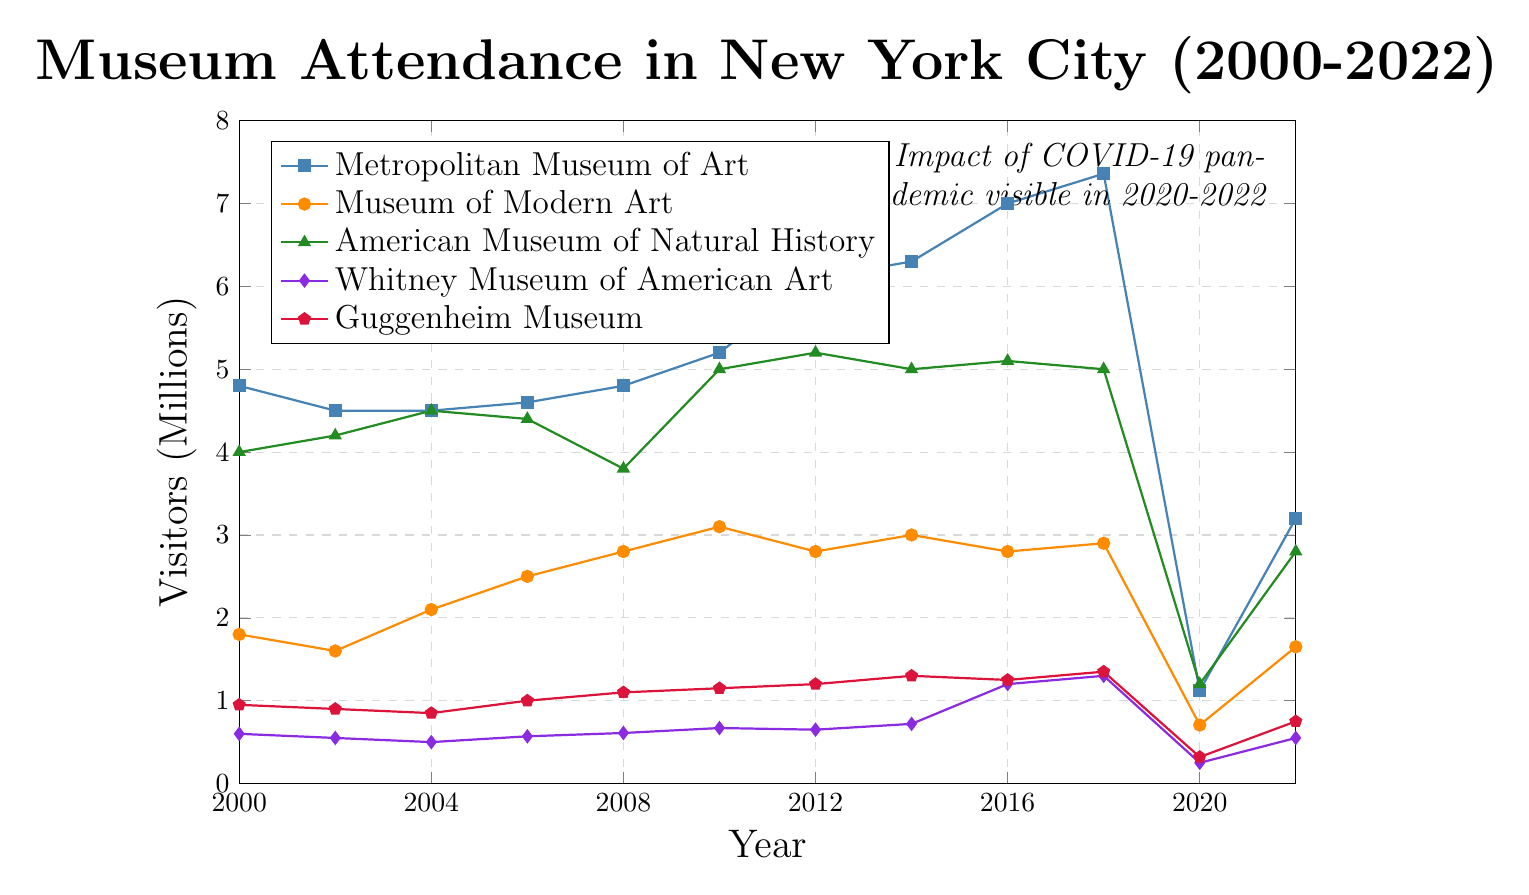How did attendance at the Guggenheim Museum change between 2000 and 2018? Looking at the Guggenheim Museum's line in the figure, the attendance in 2000 was 0.95 million and increased to 1.35 million in 2018. Subtracting the 2000 value from the 2018 value gives the change: 1.35 - 0.95 = 0.4 million.
Answer: Increased by 0.4 million Which museum had the highest attendance in 2016 and how much was it? Checking all five lines in the figure for 2016, the Metropolitan Museum of Art had the highest attendance at 7.0 million visitors.
Answer: Metropolitan Museum of Art with 7.0 million visitors Compare the drop in attendance between 2019 and 2020 for the Metropolitan Museum of Art and the American Museum of Natural History. For the Metropolitan Museum of Art, attendance dropped from 6.479548 million in 2019 to 1.12 million in 2020, which is a drop of 5.359548 million. For the American Museum of Natural History, attendance dropped from 5 million to 1.2 million in the same period, a drop of 3.8 million. Therefore, the Metropolitan Museum of Art had a larger drop.
Answer: Metropolitan Museum of Art had a larger drop, 5.359548 million What were the attendance figures for the Museum of Modern Art in 2020 and 2022, and what was the percentage increase? The figure shows the Museum of Modern Art had 0.706060 million visitors in 2020 and 1.65 million in 2022. The percentage increase is calculated as ((1.65 - 0.706060) / 0.706060) * 100 = approximately 133.65%.
Answer: 133.65% Which year showed the largest overall drop in museum attendance for the American Museum of Natural History, and how much did it drop by? The largest drop in attendance for the American Museum of Natural History occurred between 2018 and 2020. The attendance was 5 million in 2018 and dropped to 1.2 million in 2020, a reduction of 3.8 million.
Answer: 2020, dropped by 3.8 million Between 2004 and 2008, which museum showed the most consistent increase in attendance? Plotting points between 2004 and 2008 for each museum, the Metropolitan Museum of Art had values of 4.5 million to 4.8 million, making it less consistent. The most consistent increase seems to be the Museum of Modern Art, which increased from 2.1 million in 2004 to 2.8 million in 2008, a steady rise at each data point.
Answer: Museum of Modern Art What was the attendance for the Whitney Museum of American Art in 2018, and how did it compare to 2000? The Whitney Museum of American Art had 1.3 million visitors in 2018. In 2000, it had 0.6 million visitors. Comparing the two, the 2018 attendance was more than double that of 2000.
Answer: 2018 attendance was more than double compared to 2000 Which museum recovered the most in attendance from 2020 to 2022? By examining the lines from 2020 to 2022, the Metropolitan Museum of Art increased from 1.12 million to 3.2 million visitors, a recovery of 2.08 million, which is the most significant increase among the museums.
Answer: Metropolitan Museum of Art with a recovery of 2.08 million 